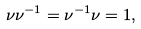<formula> <loc_0><loc_0><loc_500><loc_500>\nu \nu ^ { - 1 } = \nu ^ { - 1 } \nu = 1 ,</formula> 